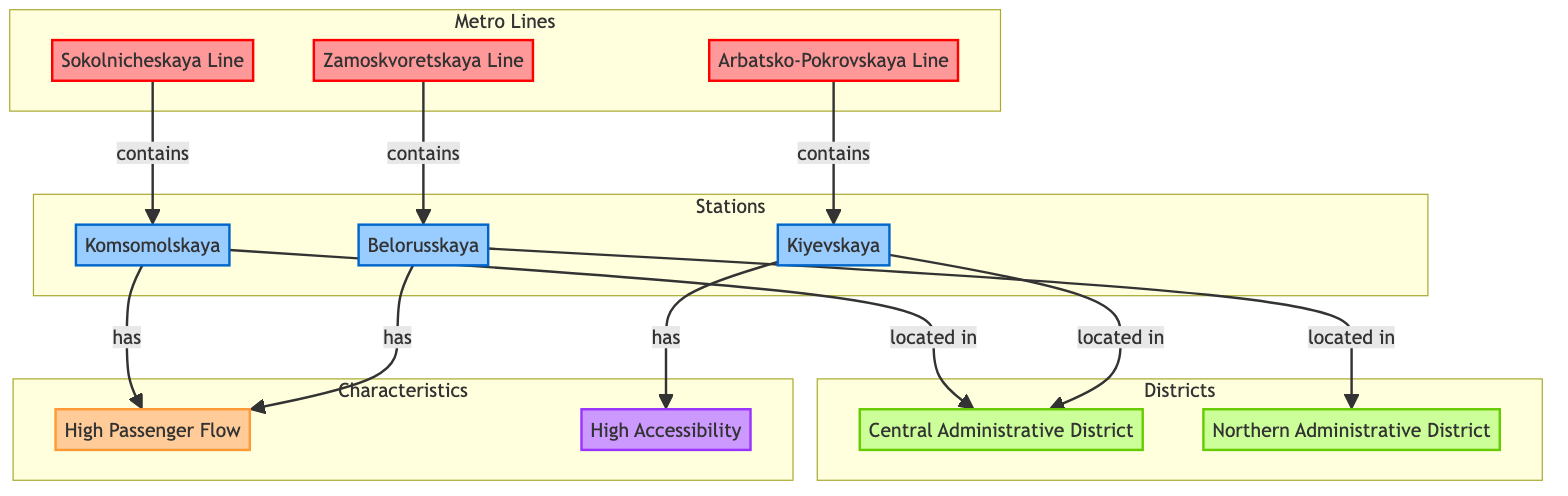What is the name of the first metro line listed in the diagram? The first metro line listed in the diagram is the Sokolnicheskaya Line, as it is the first line mentioned before the others.
Answer: Sokolnicheskaya Line Which district does Komsomolskaya station belong to? Komsomolskaya station is located in the Central Administrative District, as indicated by the direct connection shown in the diagram.
Answer: Central Administrative District How many stations are represented in the diagram? There are three stations shown in the diagram: Komsomolskaya, Belorusskaya, and Kievskaya. Therefore, counting these stations gives us a total of three.
Answer: 3 What characteristic does the Komsomolskaya station have? Komsomolskaya station has a high passenger flow, as depicted by the connection labeled 'has' coming from this station towards the passenger flow characteristic node.
Answer: High Passenger Flow Which two lines contain stations located in the Central Administrative District? The Sokolnicheskaya Line and the Arbatsko-Pokrovskaya Line contain stations located in the Central Administrative District, as Komsomolskaya and Kievskaya are both in this district.
Answer: Sokolnicheskaya Line, Arbatsko-Pokrovskaya Line What type of passenger characteristic does Belorusskaya station have? Belorusskaya station has a high passenger flow as shown by the connection labeled 'has' that leads from the station to the passenger flow characteristic.
Answer: High Passenger Flow Which line is associated with the station located in the Northern Administrative District? The Zamoskvoretskaya Line is associated with the Belorusskaya station, which is located in the Northern Administrative District as per the connections defined in the diagram.
Answer: Zamoskvoretskaya Line What is the flow type characteristic associated with Kievskaya station? Kievskaya station has high accessibility as indicated by the connection 'has', which leads to the high accessibility feature node.
Answer: High Accessibility In total, how many districts are represented in the diagram? The diagram represents two districts: the Central Administrative District and the Northern Administrative District. Counting these gives us a total of two districts.
Answer: 2 